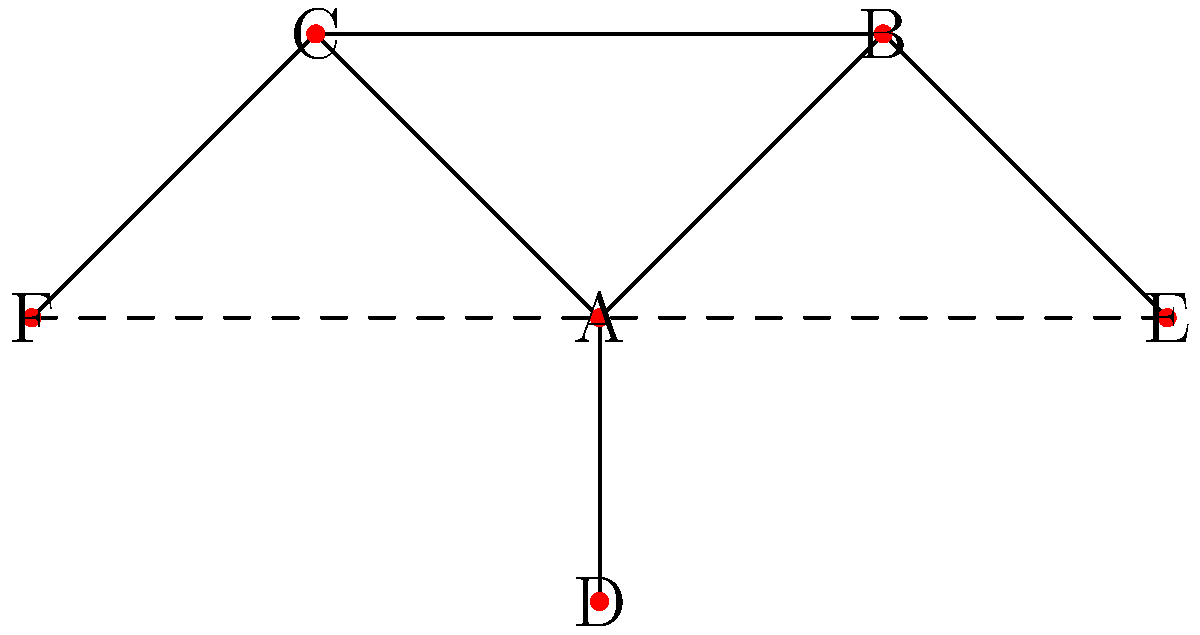In your latest novel, you've created a complex web of character relationships. The network graph above represents these relationships, where each node is a character and each edge represents a significant interaction or relationship between characters. Character A is the protagonist, while E and F are antagonists. If you were to remove character A from the story, which character would be best positioned to take on the role of the new protagonist based on their connections in the network? To determine the best character to take on the role of the new protagonist, we need to analyze the network graph and consider each character's connections:

1. Character A (current protagonist):
   - Connected to B, C, and D
   - Removing A would leave these connections open

2. Character B:
   - Connected to A, C, and E
   - After removing A, B would still be connected to C and E

3. Character C:
   - Connected to A, B, and F
   - After removing A, C would still be connected to B and F

4. Character D:
   - Only connected to A
   - After removing A, D would be isolated

5. Character E (antagonist):
   - Connected to B and F (dashed line)
   - Not suitable as a protagonist

6. Character F (antagonist):
   - Connected to C and E (dashed line)
   - Not suitable as a protagonist

Analyzing these connections, we can see that:
- Character D is not a good choice as it would be isolated after removing A.
- Characters E and F are antagonists, so they're not suitable for the protagonist role.
- Character B and C both have two remaining connections after removing A.

However, Character B has a slight advantage because:
1. It's connected to both an antagonist (E) and another main character (C), providing more potential for conflict and interaction.
2. It maintains a bridge between the remaining main characters (C) and the antagonists (E), which could create interesting plot dynamics.

Therefore, Character B would be best positioned to take on the role of the new protagonist based on their connections in the network.
Answer: Character B 